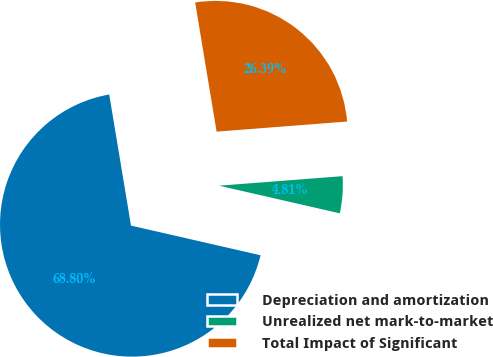Convert chart to OTSL. <chart><loc_0><loc_0><loc_500><loc_500><pie_chart><fcel>Depreciation and amortization<fcel>Unrealized net mark-to-market<fcel>Total Impact of Significant<nl><fcel>68.8%<fcel>4.81%<fcel>26.39%<nl></chart> 